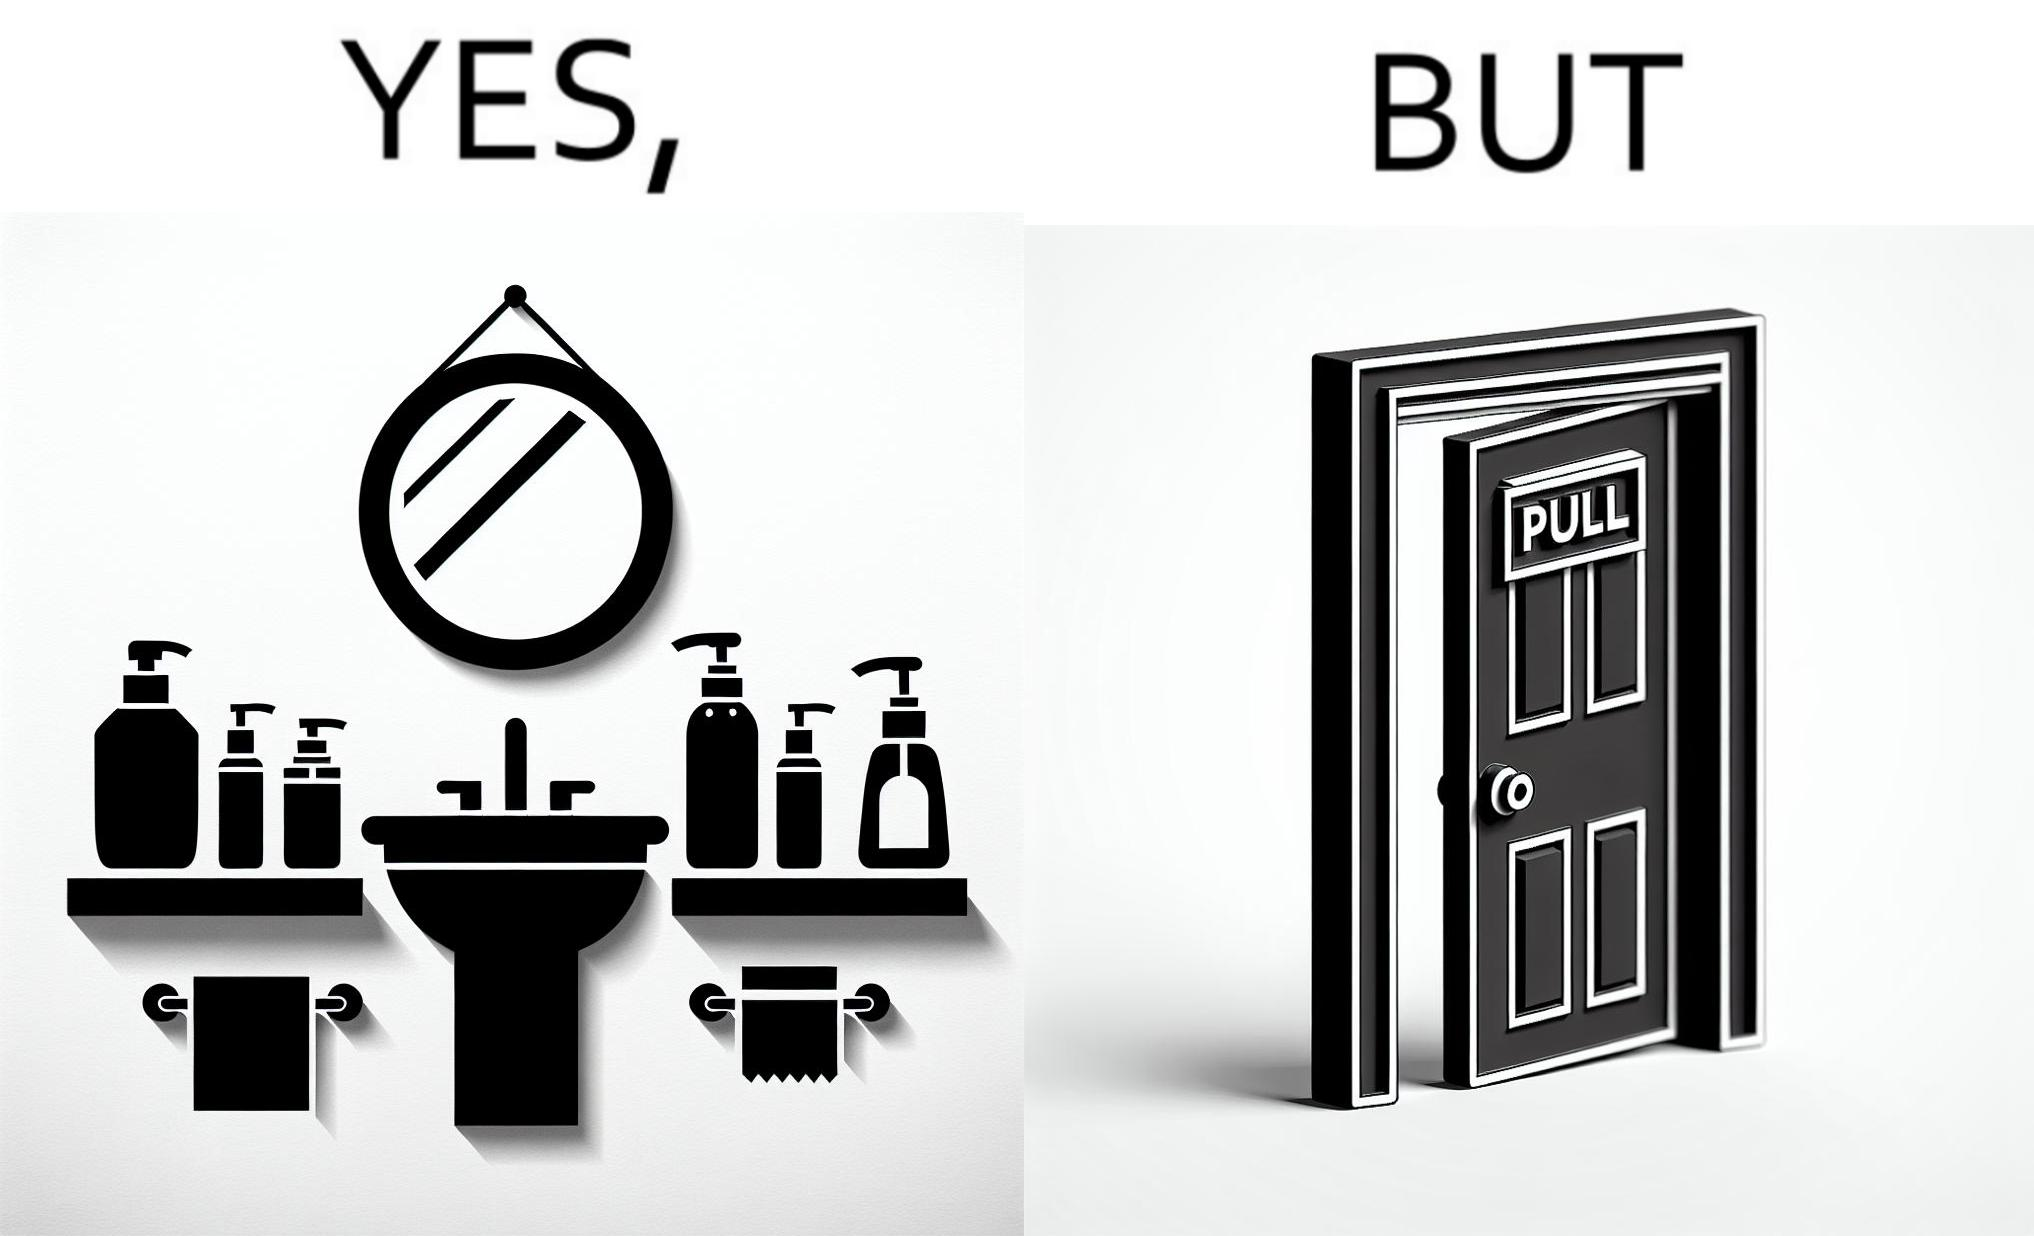Describe what you see in the left and right parts of this image. In the left part of the image: a basin with different handwashes and paper roll around it to clean hands with a mirror in front In the right part of the image: a door with a pull sign and handle on it 